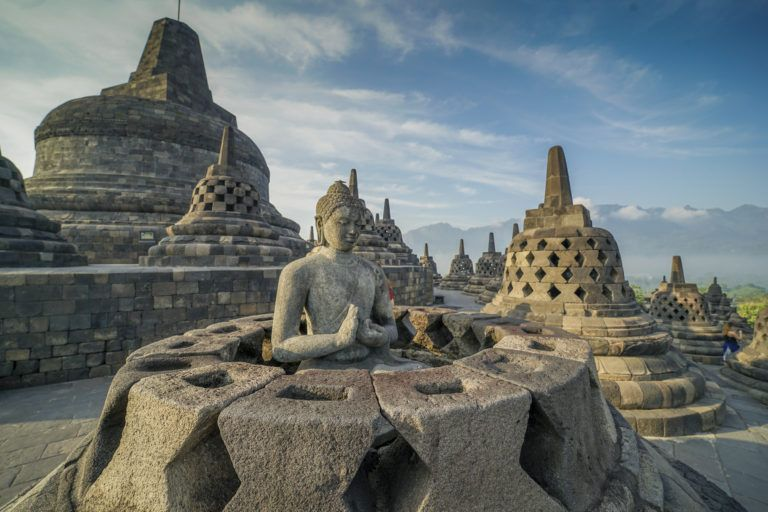What's happening in the scene? The image captures the stunning Borobodur Temple in Indonesia, a majestic and iconic Buddhist landmark known for its architectural grandeur. The photograph highlights the temple's intricate stone structures, which ascend in multiple levels towards the sky, each adorned with characteristic bell-shaped stupas. In the foreground, a serene stone statue of a seated Buddha adds a tranquil and spiritual presence to the scene. The perspective, captured from a low angle, dramatically emphasizes the temple’s towering height, giving it an almost ethereal aspiration towards the heavens. Completing this picturesque scene is a clear blue sky dotted with wispy clouds, which serves as a perfect backdrop and enhances the overall visual contrast and splendor of this architectural masterpiece. 